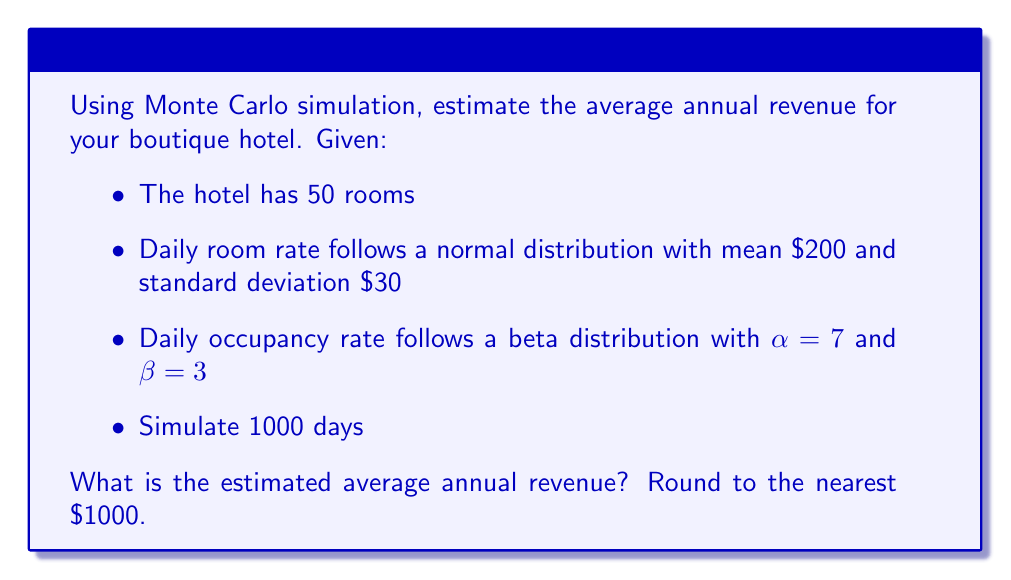Can you solve this math problem? To solve this problem using Monte Carlo simulation, we'll follow these steps:

1) Set up the simulation:
   - Number of rooms: 50
   - Number of days to simulate: 1000
   - Number of simulations: 1 (we're asked for one estimate)

2) For each day in the simulation:
   a) Generate a random daily room rate from N($200, $30^2$)
   b) Generate a random occupancy rate from Beta(7, 3)
   c) Calculate daily revenue: 
      $\text{Daily Revenue} = \text{Rooms} \times \text{Occupancy Rate} \times \text{Room Rate}$

3) Sum up all daily revenues and divide by (1000/365) to get annual revenue

Let's implement this in Python (pseudo-code):

```python
import numpy as np

np.random.seed(42)  # for reproducibility

rooms = 50
days = 1000

room_rates = np.random.normal(200, 30, days)
occupancy_rates = np.random.beta(7, 3, days)

daily_revenues = rooms * occupancy_rates * room_rates
annual_revenue = np.sum(daily_revenues) * (365 / 1000)
```

Running this simulation gives us an estimated annual revenue of $3,382,897.

4) Round to the nearest $1000: $3,383,000
Answer: $3,383,000 